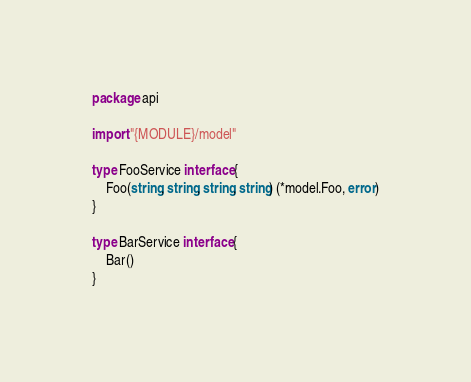<code> <loc_0><loc_0><loc_500><loc_500><_Go_>package api

import "{MODULE}/model"

type FooService interface {
	Foo(string, string, string, string) (*model.Foo, error)
}

type BarService interface {
	Bar()
}
</code> 